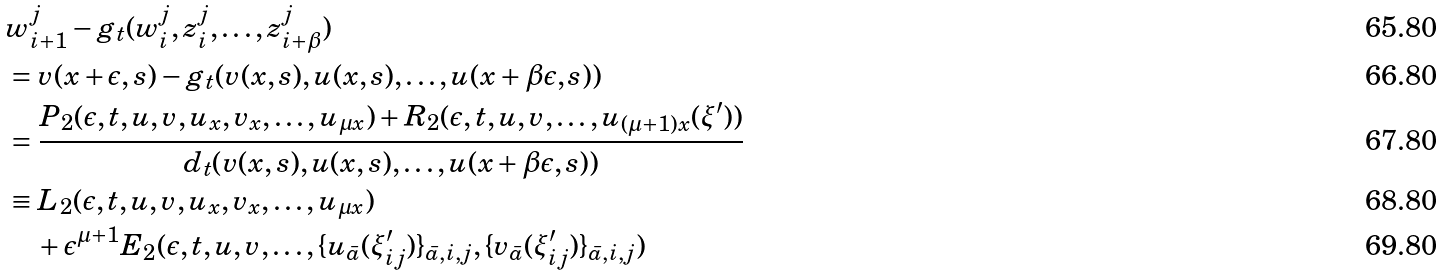Convert formula to latex. <formula><loc_0><loc_0><loc_500><loc_500>& w _ { i + 1 } ^ { j } - g _ { t } ( w _ { i } ^ { j } , z _ { i } ^ { j } , \dots , z _ { i + \beta } ^ { j } ) \\ & = v ( x + \epsilon , s ) - g _ { t } ( v ( x , s ) , u ( x , s ) , \dots , u ( x + \beta \epsilon , s ) ) \\ & = \frac { P _ { 2 } ( \epsilon , t , u , v , u _ { x } , v _ { x } , \dots , u _ { \mu x } ) + R _ { 2 } ( \epsilon , t , u , v , \dots , u _ { ( \mu + 1 ) x } ( \xi ^ { \prime } ) ) } { d _ { t } ( v ( x , s ) , u ( x , s ) , \dots , u ( x + \beta \epsilon , s ) ) } \\ & \equiv L _ { 2 } ( \epsilon , t , u , v , u _ { x } , v _ { x } , \dots , u _ { \mu x } ) \\ & \quad + \epsilon ^ { \mu + 1 } { E } _ { 2 } ( \epsilon , t , u , v , \dots , \{ u _ { \bar { a } } ( \xi ^ { \prime } _ { i j } ) \} _ { \bar { a } , i , j } , \{ v _ { \bar { a } } ( \xi ^ { \prime } _ { i j } ) \} _ { \bar { a } , i , j } )</formula> 